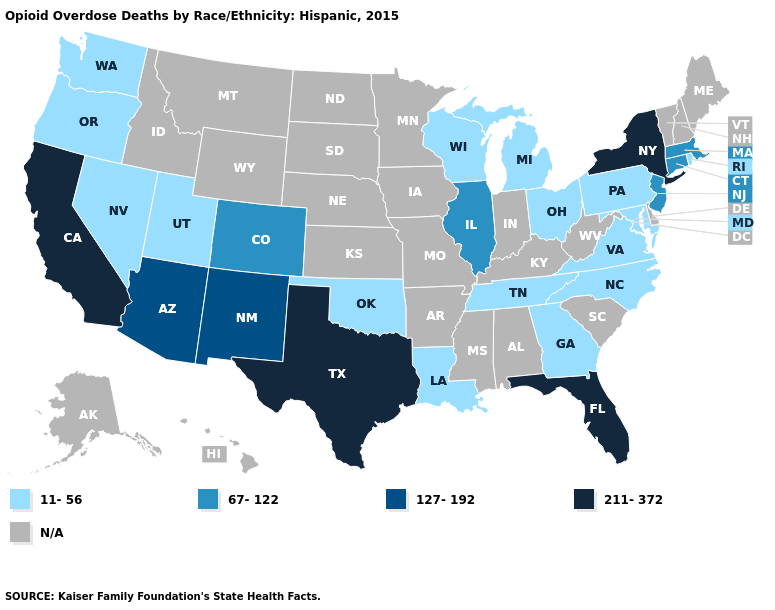Name the states that have a value in the range 11-56?
Concise answer only. Georgia, Louisiana, Maryland, Michigan, Nevada, North Carolina, Ohio, Oklahoma, Oregon, Pennsylvania, Rhode Island, Tennessee, Utah, Virginia, Washington, Wisconsin. Is the legend a continuous bar?
Answer briefly. No. Among the states that border Michigan , which have the lowest value?
Concise answer only. Ohio, Wisconsin. Which states have the lowest value in the USA?
Keep it brief. Georgia, Louisiana, Maryland, Michigan, Nevada, North Carolina, Ohio, Oklahoma, Oregon, Pennsylvania, Rhode Island, Tennessee, Utah, Virginia, Washington, Wisconsin. What is the lowest value in the South?
Write a very short answer. 11-56. What is the value of Maine?
Keep it brief. N/A. What is the value of Georgia?
Quick response, please. 11-56. Which states have the lowest value in the South?
Concise answer only. Georgia, Louisiana, Maryland, North Carolina, Oklahoma, Tennessee, Virginia. What is the lowest value in states that border New York?
Keep it brief. 11-56. Name the states that have a value in the range 11-56?
Write a very short answer. Georgia, Louisiana, Maryland, Michigan, Nevada, North Carolina, Ohio, Oklahoma, Oregon, Pennsylvania, Rhode Island, Tennessee, Utah, Virginia, Washington, Wisconsin. What is the highest value in the USA?
Be succinct. 211-372. Name the states that have a value in the range 67-122?
Give a very brief answer. Colorado, Connecticut, Illinois, Massachusetts, New Jersey. 